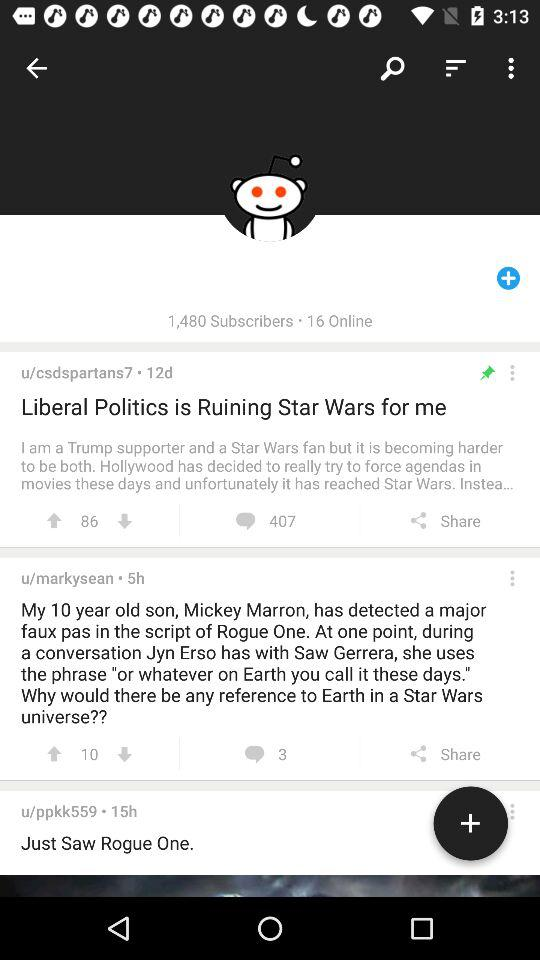Which applications are available for sharing?
When the provided information is insufficient, respond with <no answer>. <no answer> 